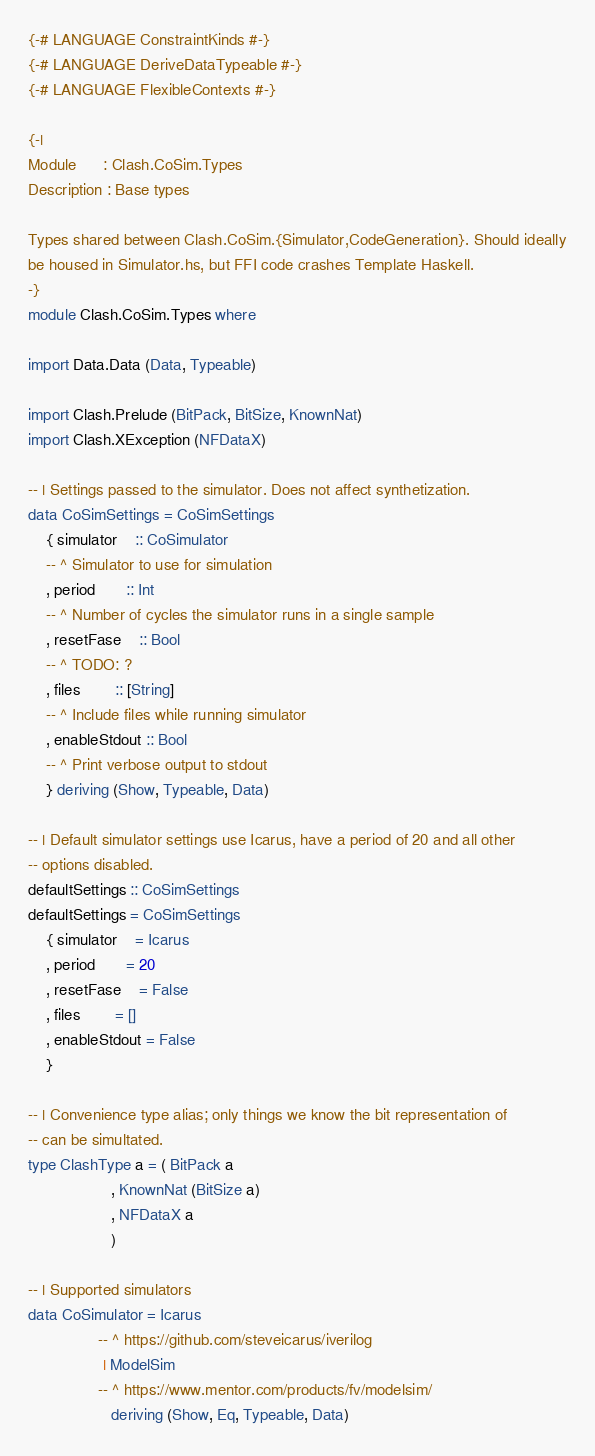Convert code to text. <code><loc_0><loc_0><loc_500><loc_500><_Haskell_>{-# LANGUAGE ConstraintKinds #-}
{-# LANGUAGE DeriveDataTypeable #-}
{-# LANGUAGE FlexibleContexts #-}

{-|
Module      : Clash.CoSim.Types
Description : Base types

Types shared between Clash.CoSim.{Simulator,CodeGeneration}. Should ideally
be housed in Simulator.hs, but FFI code crashes Template Haskell.
-}
module Clash.CoSim.Types where

import Data.Data (Data, Typeable)

import Clash.Prelude (BitPack, BitSize, KnownNat)
import Clash.XException (NFDataX)

-- | Settings passed to the simulator. Does not affect synthetization.
data CoSimSettings = CoSimSettings
    { simulator    :: CoSimulator
    -- ^ Simulator to use for simulation
    , period       :: Int
    -- ^ Number of cycles the simulator runs in a single sample
    , resetFase    :: Bool
    -- ^ TODO: ?
    , files        :: [String]
    -- ^ Include files while running simulator
    , enableStdout :: Bool
    -- ^ Print verbose output to stdout
    } deriving (Show, Typeable, Data)

-- | Default simulator settings use Icarus, have a period of 20 and all other
-- options disabled.
defaultSettings :: CoSimSettings
defaultSettings = CoSimSettings
    { simulator    = Icarus
    , period       = 20
    , resetFase    = False
    , files        = []
    , enableStdout = False
    }

-- | Convenience type alias; only things we know the bit representation of
-- can be simultated.
type ClashType a = ( BitPack a
                   , KnownNat (BitSize a)
                   , NFDataX a
                   )

-- | Supported simulators
data CoSimulator = Icarus
                -- ^ https://github.com/steveicarus/iverilog
                 | ModelSim
                -- ^ https://www.mentor.com/products/fv/modelsim/
                   deriving (Show, Eq, Typeable, Data)
</code> 